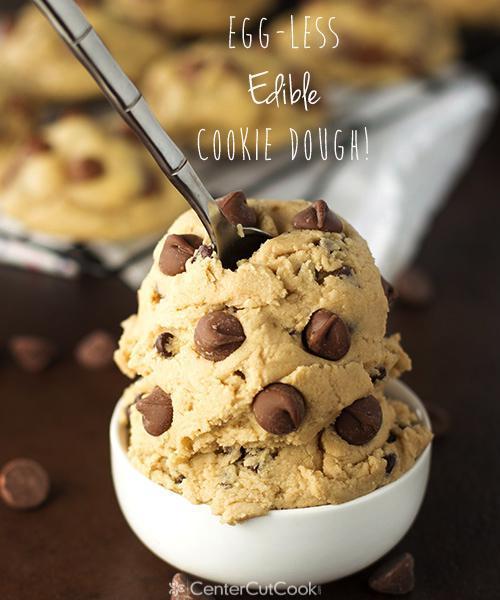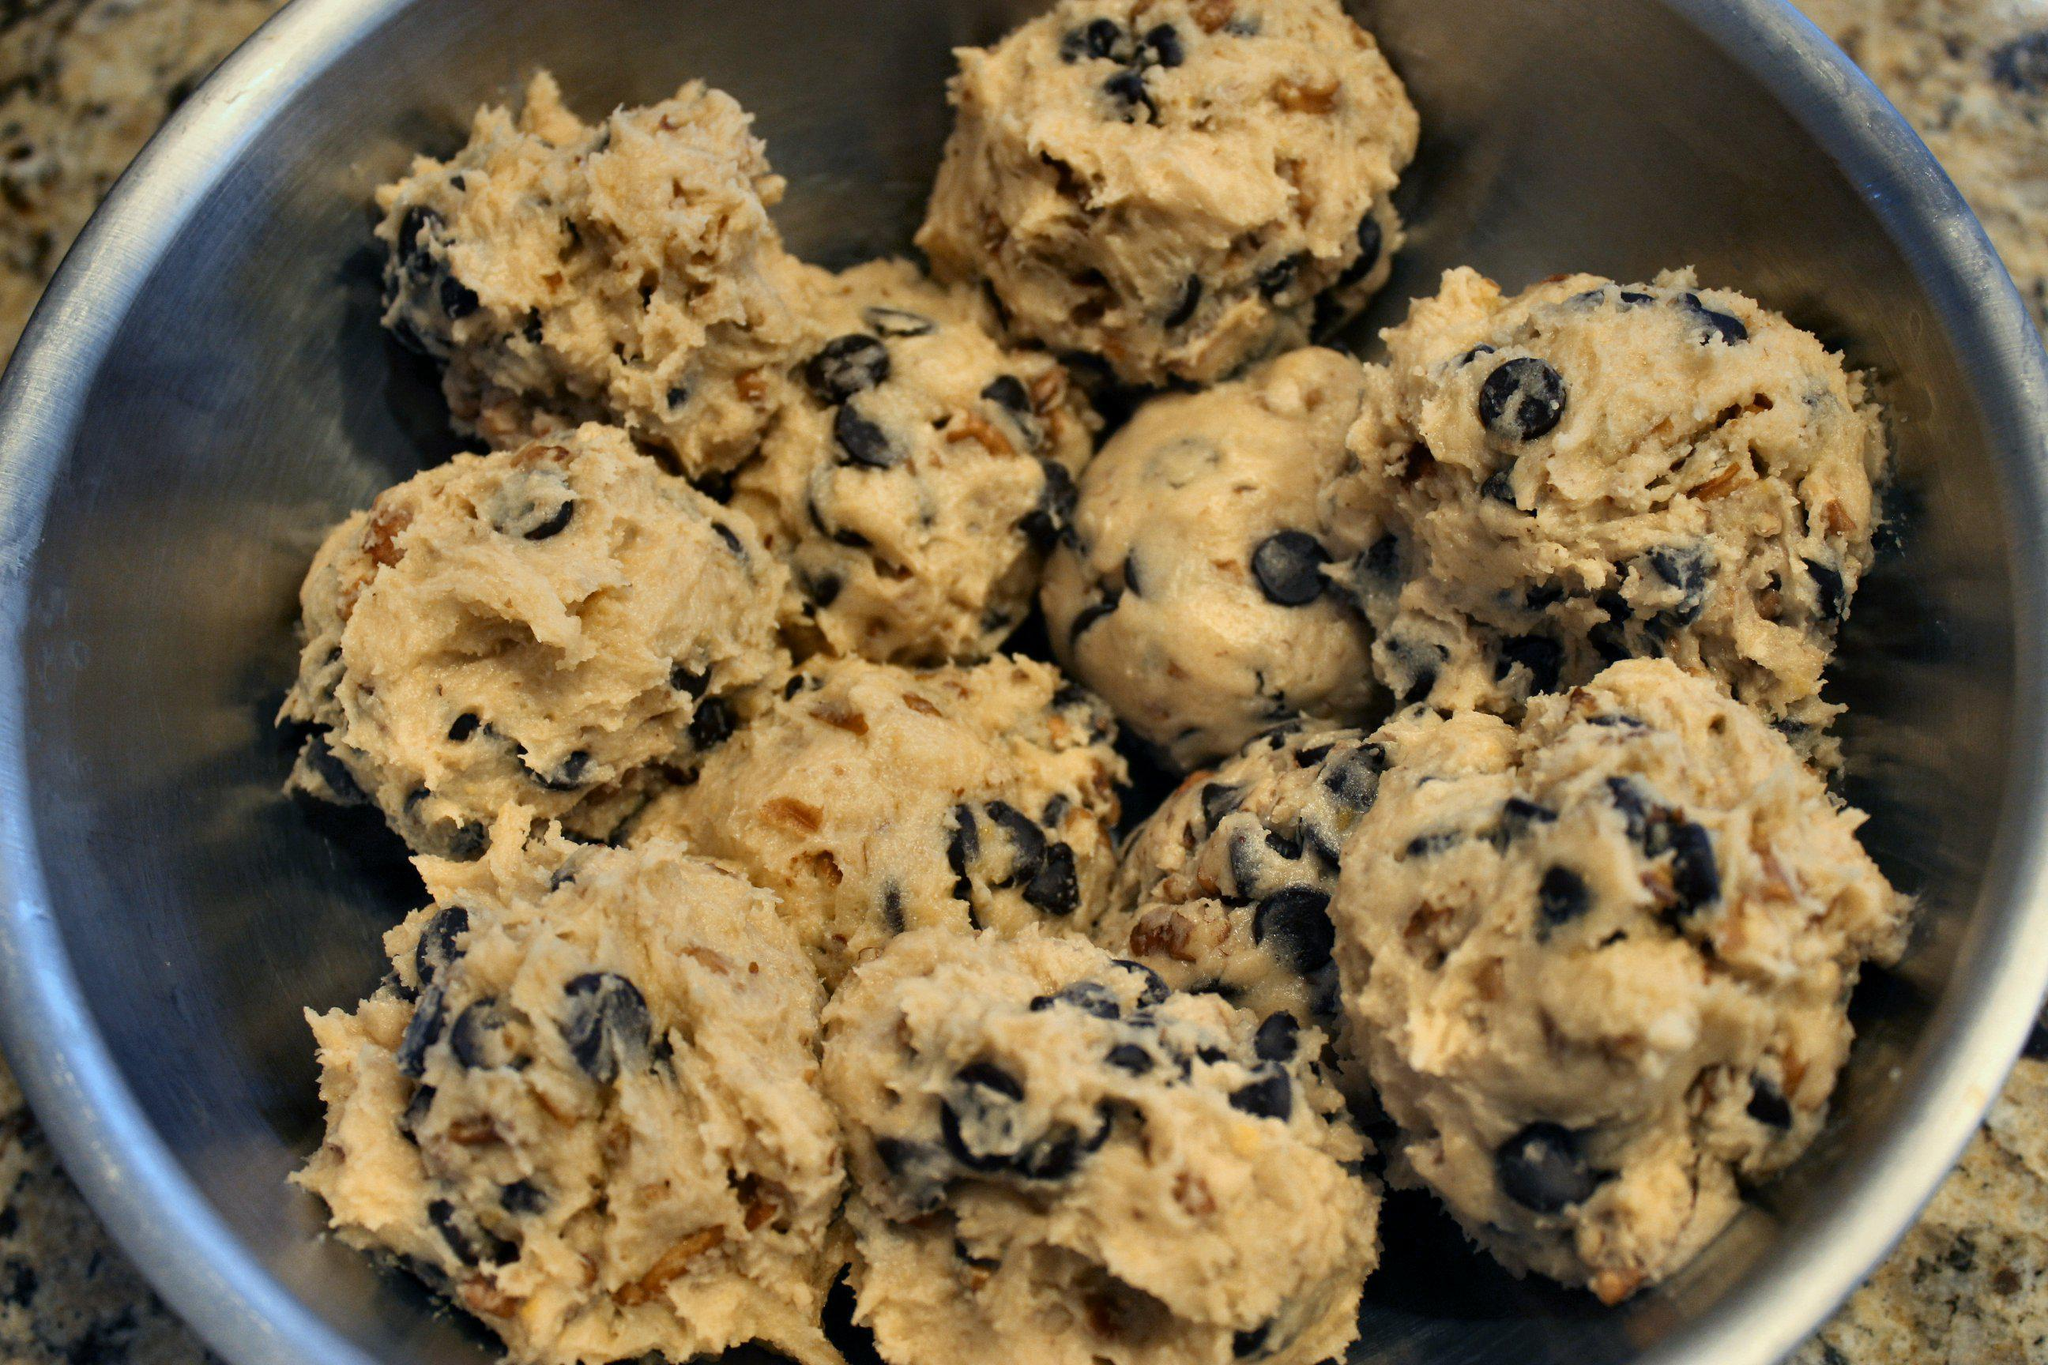The first image is the image on the left, the second image is the image on the right. Given the left and right images, does the statement "Each image shows cookie dough in a bowl with the handle of a utensil sticking out of it." hold true? Answer yes or no. No. The first image is the image on the left, the second image is the image on the right. For the images displayed, is the sentence "A wooden spoon touching a dough is visible." factually correct? Answer yes or no. No. 